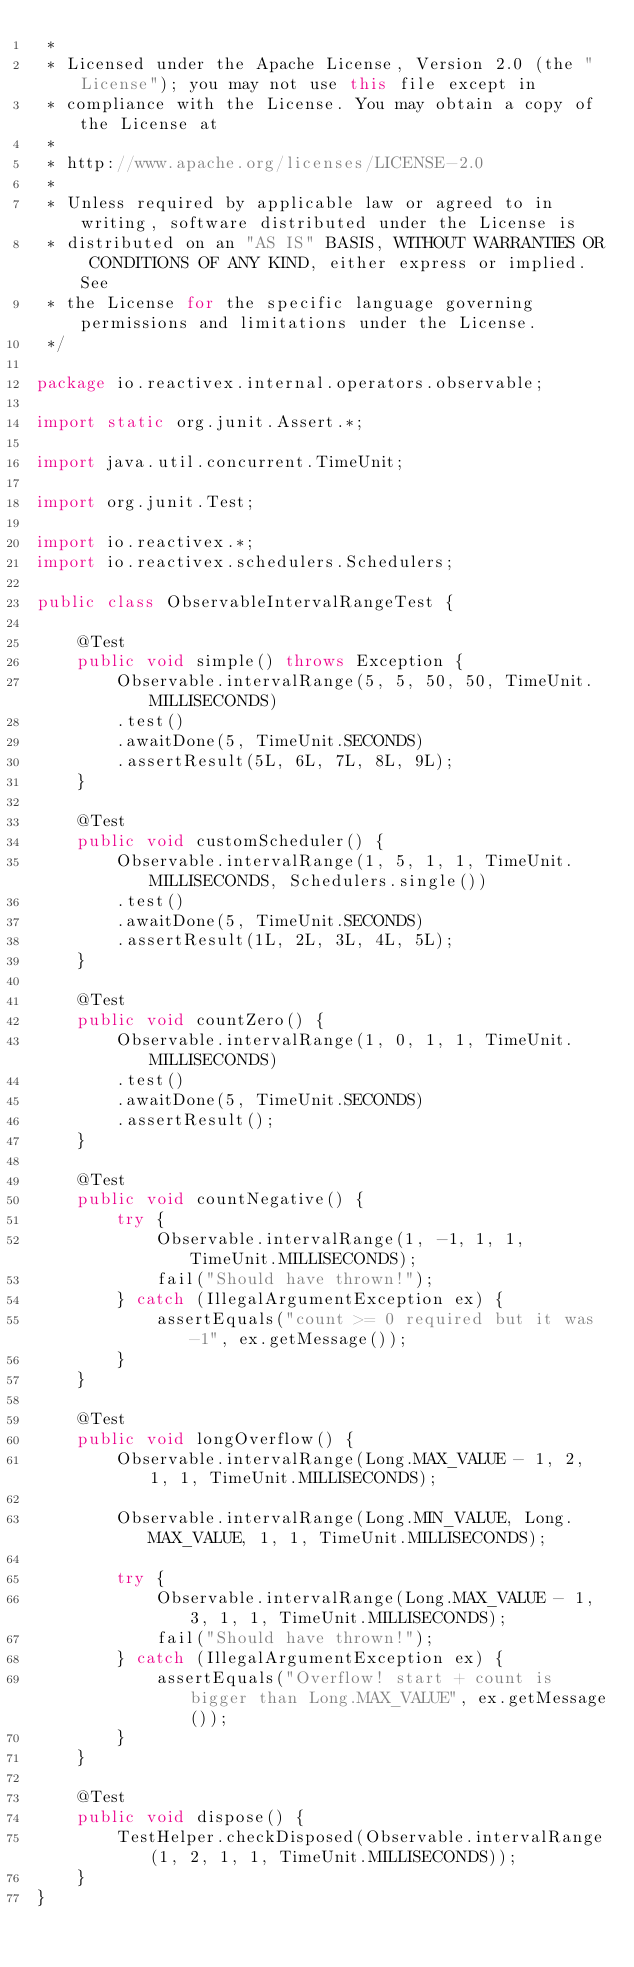Convert code to text. <code><loc_0><loc_0><loc_500><loc_500><_Java_> *
 * Licensed under the Apache License, Version 2.0 (the "License"); you may not use this file except in
 * compliance with the License. You may obtain a copy of the License at
 *
 * http://www.apache.org/licenses/LICENSE-2.0
 *
 * Unless required by applicable law or agreed to in writing, software distributed under the License is
 * distributed on an "AS IS" BASIS, WITHOUT WARRANTIES OR CONDITIONS OF ANY KIND, either express or implied. See
 * the License for the specific language governing permissions and limitations under the License.
 */

package io.reactivex.internal.operators.observable;

import static org.junit.Assert.*;

import java.util.concurrent.TimeUnit;

import org.junit.Test;

import io.reactivex.*;
import io.reactivex.schedulers.Schedulers;

public class ObservableIntervalRangeTest {

    @Test
    public void simple() throws Exception {
        Observable.intervalRange(5, 5, 50, 50, TimeUnit.MILLISECONDS)
        .test()
        .awaitDone(5, TimeUnit.SECONDS)
        .assertResult(5L, 6L, 7L, 8L, 9L);
    }

    @Test
    public void customScheduler() {
        Observable.intervalRange(1, 5, 1, 1, TimeUnit.MILLISECONDS, Schedulers.single())
        .test()
        .awaitDone(5, TimeUnit.SECONDS)
        .assertResult(1L, 2L, 3L, 4L, 5L);
    }

    @Test
    public void countZero() {
        Observable.intervalRange(1, 0, 1, 1, TimeUnit.MILLISECONDS)
        .test()
        .awaitDone(5, TimeUnit.SECONDS)
        .assertResult();
    }

    @Test
    public void countNegative() {
        try {
            Observable.intervalRange(1, -1, 1, 1, TimeUnit.MILLISECONDS);
            fail("Should have thrown!");
        } catch (IllegalArgumentException ex) {
            assertEquals("count >= 0 required but it was -1", ex.getMessage());
        }
    }

    @Test
    public void longOverflow() {
        Observable.intervalRange(Long.MAX_VALUE - 1, 2, 1, 1, TimeUnit.MILLISECONDS);

        Observable.intervalRange(Long.MIN_VALUE, Long.MAX_VALUE, 1, 1, TimeUnit.MILLISECONDS);

        try {
            Observable.intervalRange(Long.MAX_VALUE - 1, 3, 1, 1, TimeUnit.MILLISECONDS);
            fail("Should have thrown!");
        } catch (IllegalArgumentException ex) {
            assertEquals("Overflow! start + count is bigger than Long.MAX_VALUE", ex.getMessage());
        }
    }

    @Test
    public void dispose() {
        TestHelper.checkDisposed(Observable.intervalRange(1, 2, 1, 1, TimeUnit.MILLISECONDS));
    }
}
</code> 